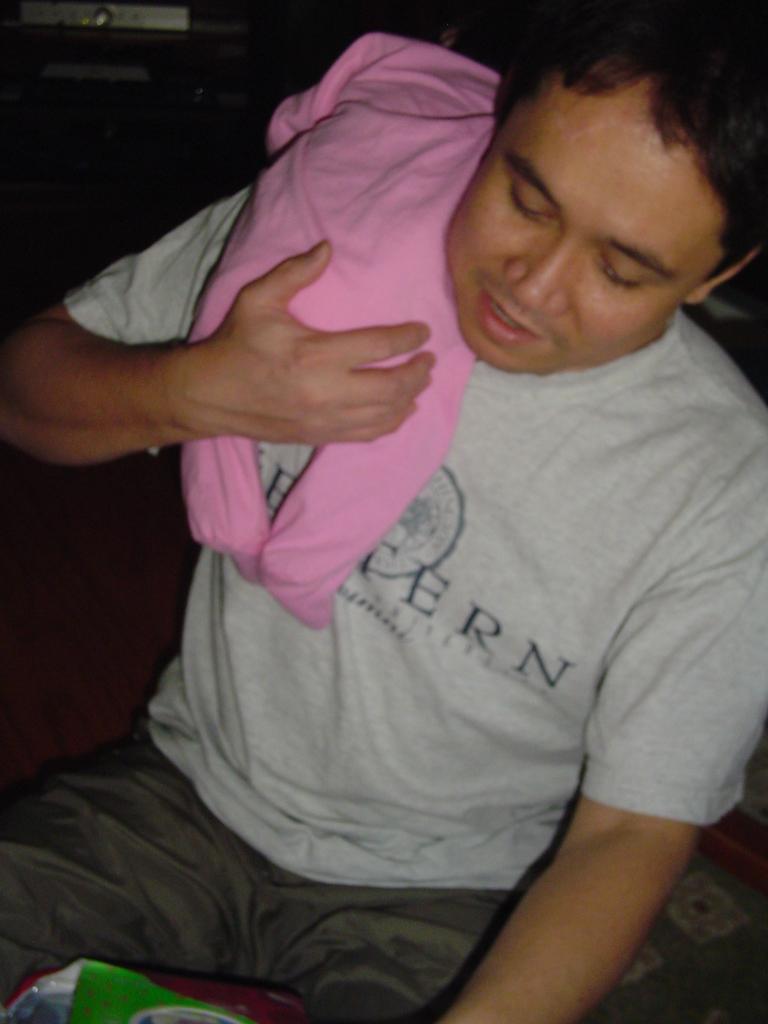How would you summarize this image in a sentence or two? In the center of the image, we can see a person holding a baby and in the background, there are some objects. 